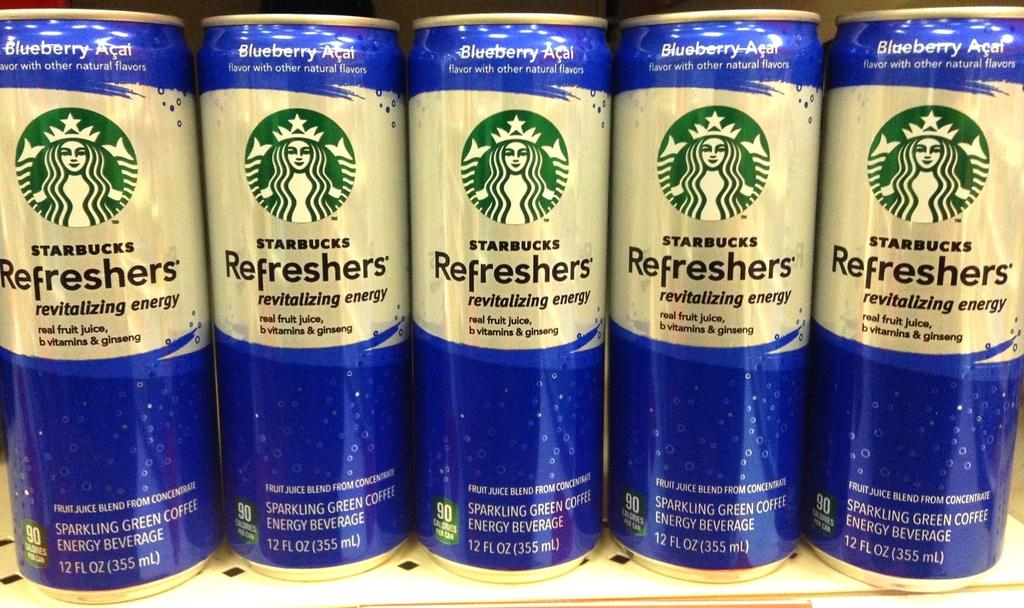<image>
Give a short and clear explanation of the subsequent image. Five Starbucks Refreshers lined up in a row. 